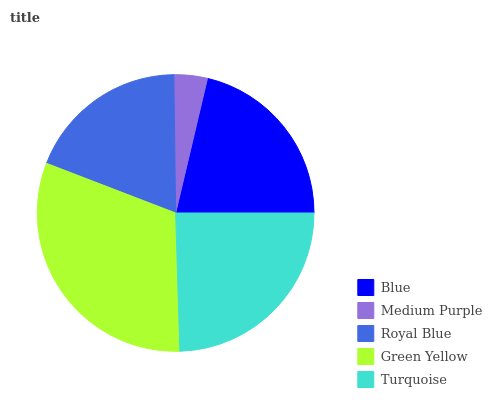Is Medium Purple the minimum?
Answer yes or no. Yes. Is Green Yellow the maximum?
Answer yes or no. Yes. Is Royal Blue the minimum?
Answer yes or no. No. Is Royal Blue the maximum?
Answer yes or no. No. Is Royal Blue greater than Medium Purple?
Answer yes or no. Yes. Is Medium Purple less than Royal Blue?
Answer yes or no. Yes. Is Medium Purple greater than Royal Blue?
Answer yes or no. No. Is Royal Blue less than Medium Purple?
Answer yes or no. No. Is Blue the high median?
Answer yes or no. Yes. Is Blue the low median?
Answer yes or no. Yes. Is Royal Blue the high median?
Answer yes or no. No. Is Turquoise the low median?
Answer yes or no. No. 